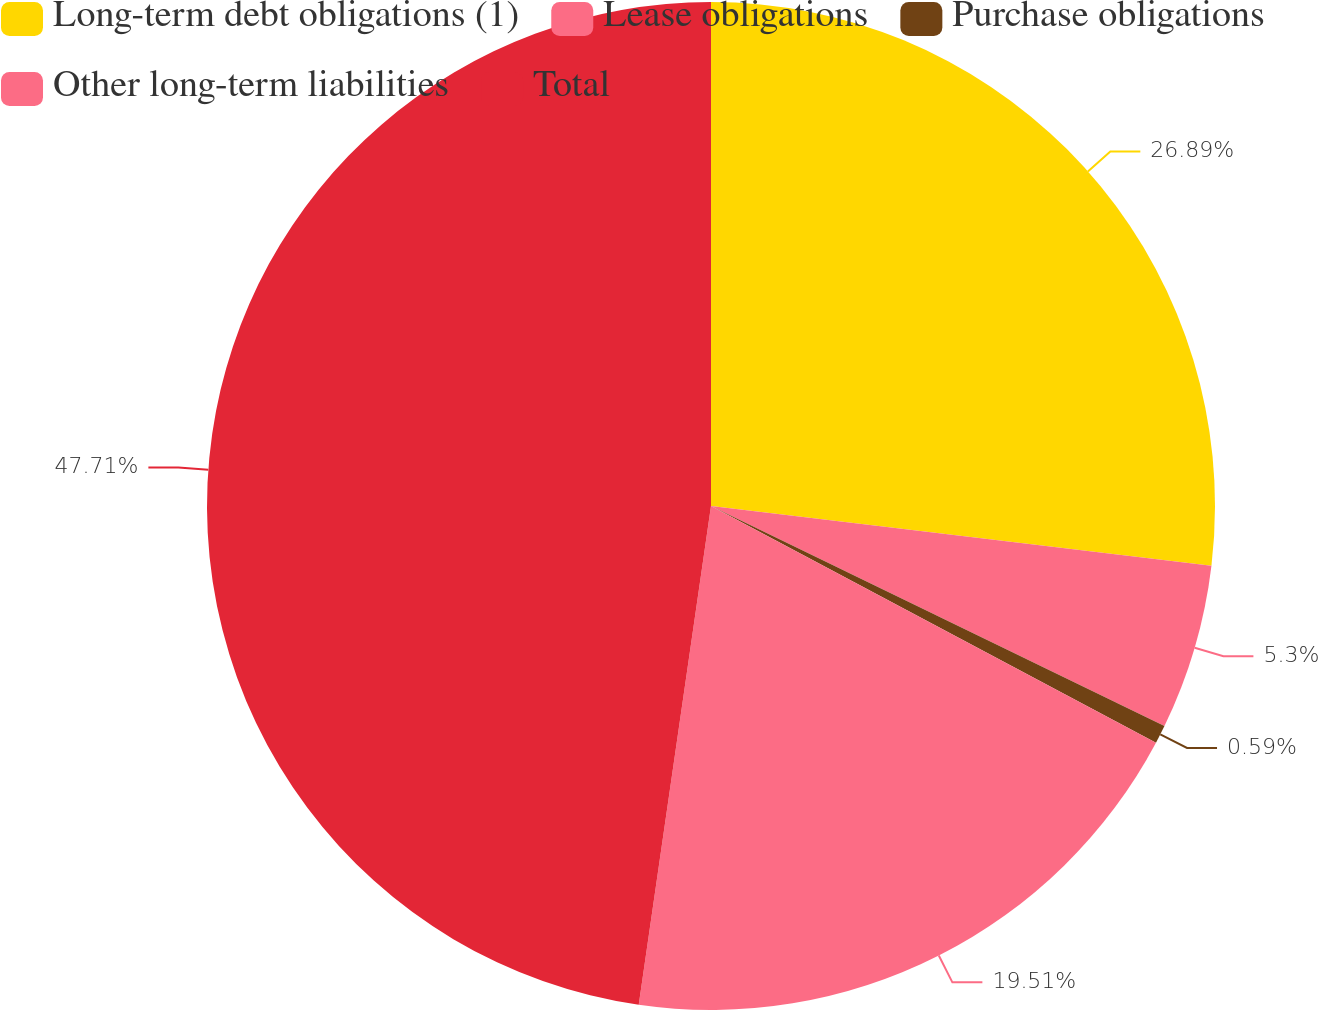Convert chart to OTSL. <chart><loc_0><loc_0><loc_500><loc_500><pie_chart><fcel>Long-term debt obligations (1)<fcel>Lease obligations<fcel>Purchase obligations<fcel>Other long-term liabilities<fcel>Total<nl><fcel>26.89%<fcel>5.3%<fcel>0.59%<fcel>19.51%<fcel>47.71%<nl></chart> 